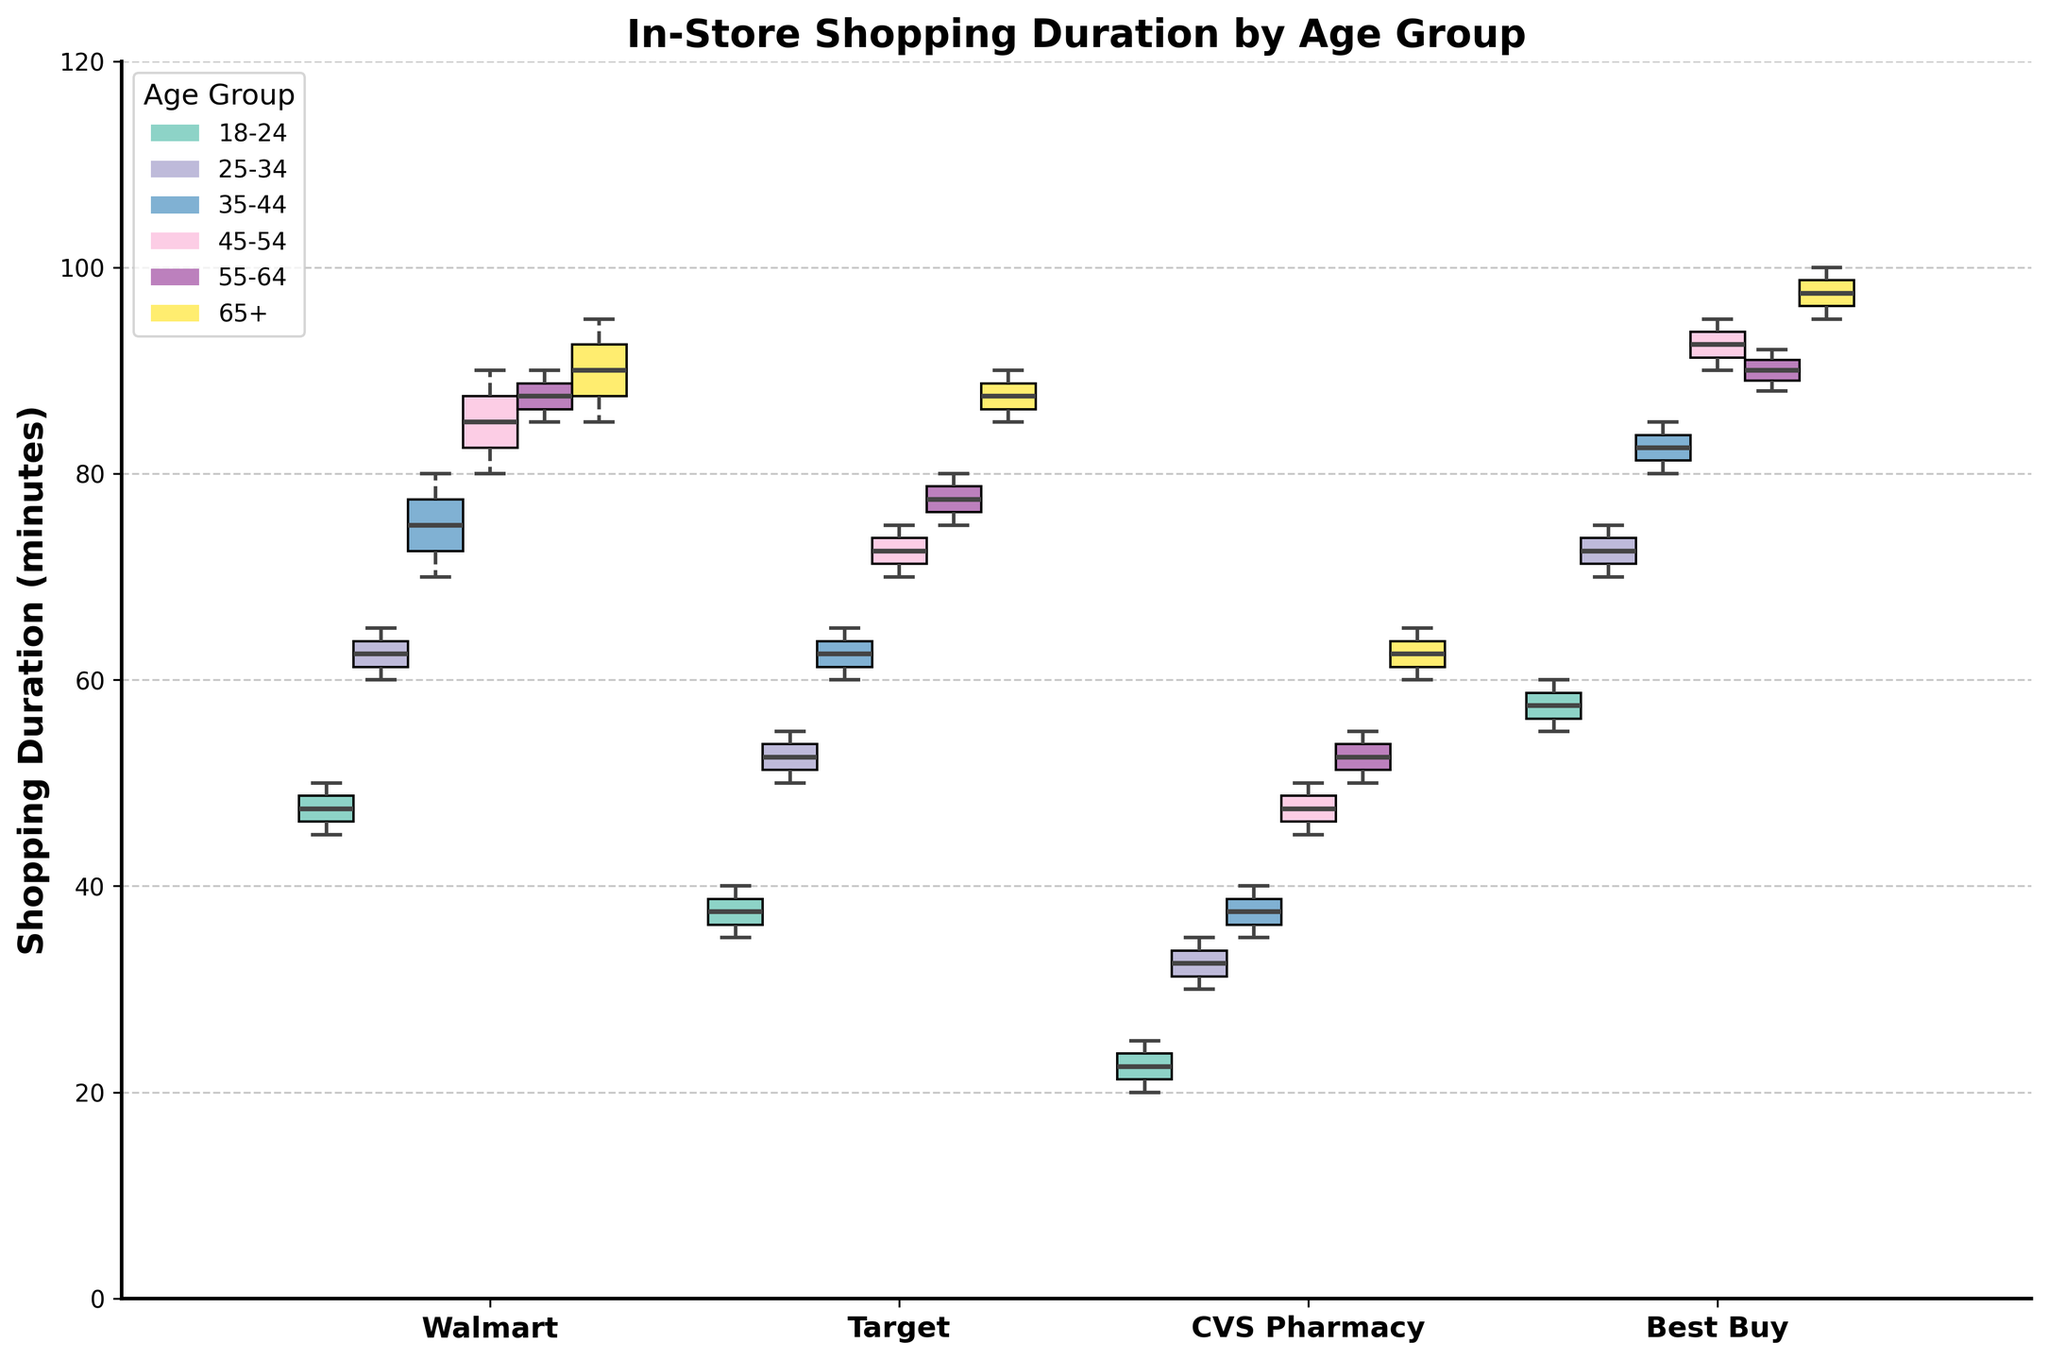What is the title of the plot? The title of the plot is displayed at the top of the figure. It reads "In-Store Shopping Duration by Age Group".
Answer: In-Store Shopping Duration by Age Group What does the y-axis represent in the plot? The y-axis, labeled "Shopping Duration (minutes)", represents the in-store shopping duration in minutes for different age groups across various stores.
Answer: Shopping Duration (minutes) Which store has the highest median shopping duration for the 45-54 age group? The box plot shows that Best Buy has the highest median for the 45-54 age group. This is observed as the median line within the Best Buy box for this age group is higher than those for other stores.
Answer: Best Buy Which age group shows the highest median shopping duration at CVS Pharmacy? By checking the median lines within the boxes at CVS Pharmacy, the 65+ age group shows the highest median shopping duration as its median line is higher than other age groups' median lines.
Answer: 65+ Is there any store where the median shopping duration decreases with increasing age groups? To answer this, one needs to examine the median lines across all age groups for each store. None of the stores show a decreasing median trend across increasing age groups, indicating the shopping duration generally increases or remains similar with age.
Answer: No Are there any age groups that have consistently high shopping durations across all stores? By looking at the medians across the stores, the 65+ age group has consistently high shopping durations, with medians visibly higher across all stores.
Answer: 65+ Which age group exhibits the widest range of shopping duration at Walmart? The range can be seen from the whiskers of the box plots. The 45-54 age group at Walmart shows the widest range as its whiskers extend further compared to other age groups. The range is the difference between the maximum and minimum whisker lengths.
Answer: 45-54 Which store has the smallest variation in shopping duration for the 25-34 age group? The smallest variation can be observed by looking for the shortest box (interquartile range) and shortest whiskers. CVS Pharmacy has the smallest variation for the 25-34 age group, as its box and whiskers are the smallest among the stores for this age group.
Answer: CVS Pharmacy Does the 18-24 age group spend more time in Target or Best Buy? By comparing the medians of the 18-24 age group at Target and Best Buy, it is observed that the median for Best Buy is higher, indicating more time spent.
Answer: Best Buy Which age group has the most outliers and at which store? By examining the dots (outliers) outside the whiskers, the 65+ age group at Best Buy has the most outliers, implying there are unusual observations compared to the rest of the data.
Answer: 65+ at Best Buy 